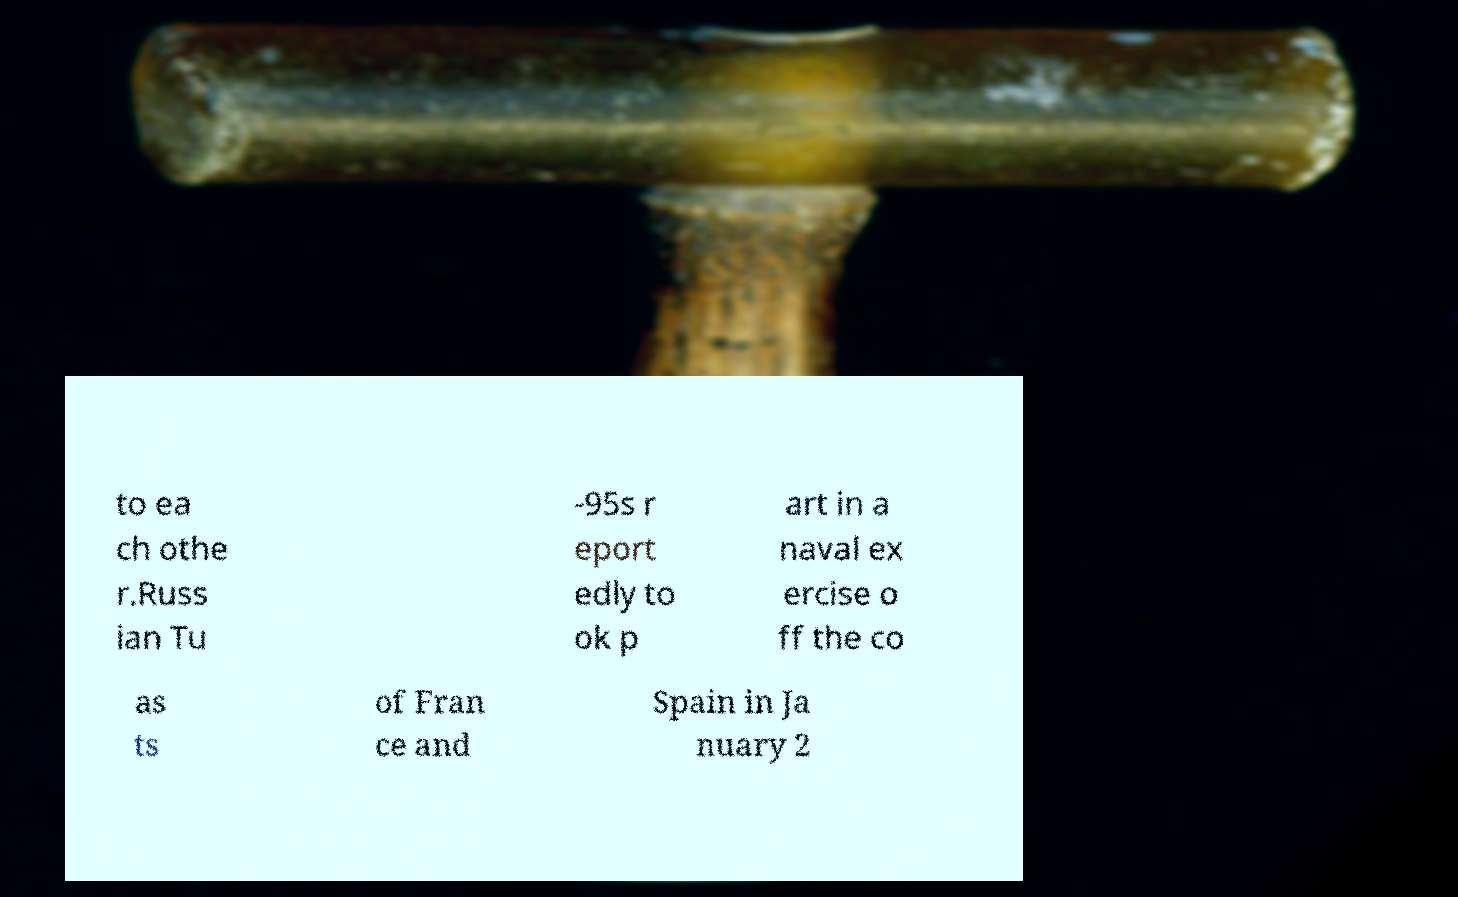I need the written content from this picture converted into text. Can you do that? to ea ch othe r.Russ ian Tu -95s r eport edly to ok p art in a naval ex ercise o ff the co as ts of Fran ce and Spain in Ja nuary 2 